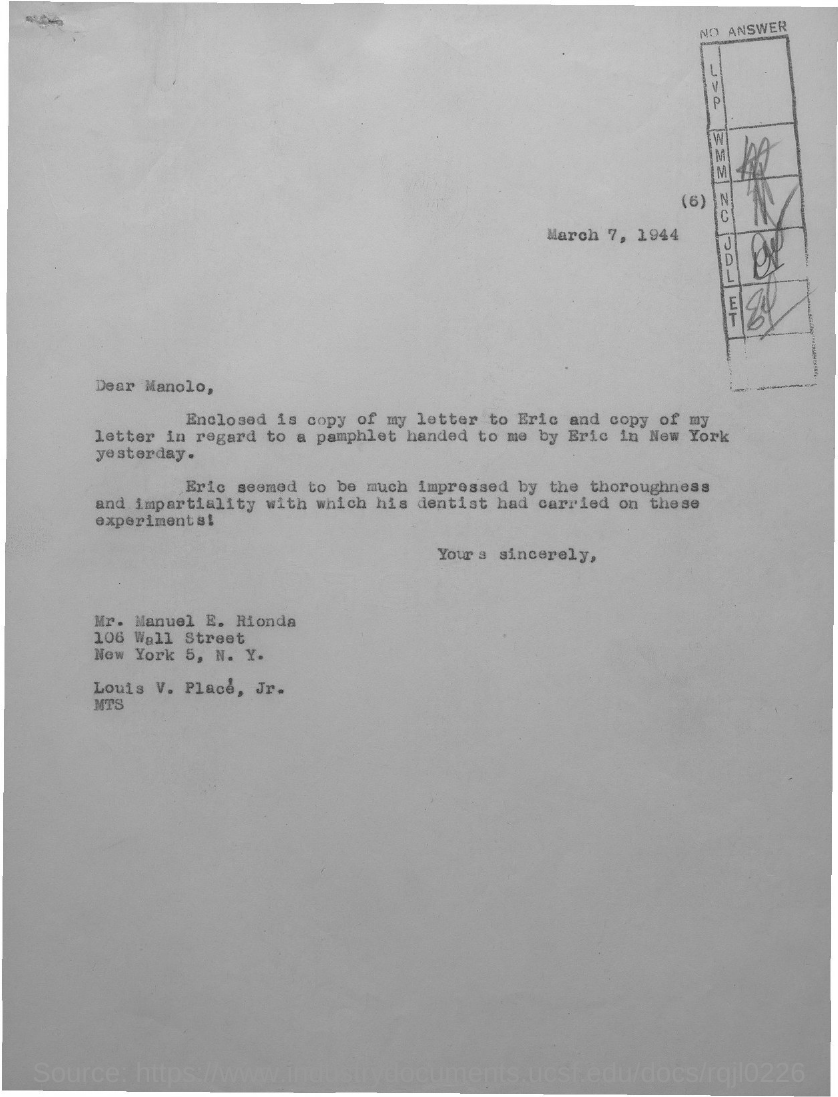What is the date on the document?
Ensure brevity in your answer.  March 7, 1944. To Whom is this letter addressed to?
Offer a very short reply. Manolo. Where was the pamphlet handed by Eric?
Ensure brevity in your answer.  NEW YORK. 